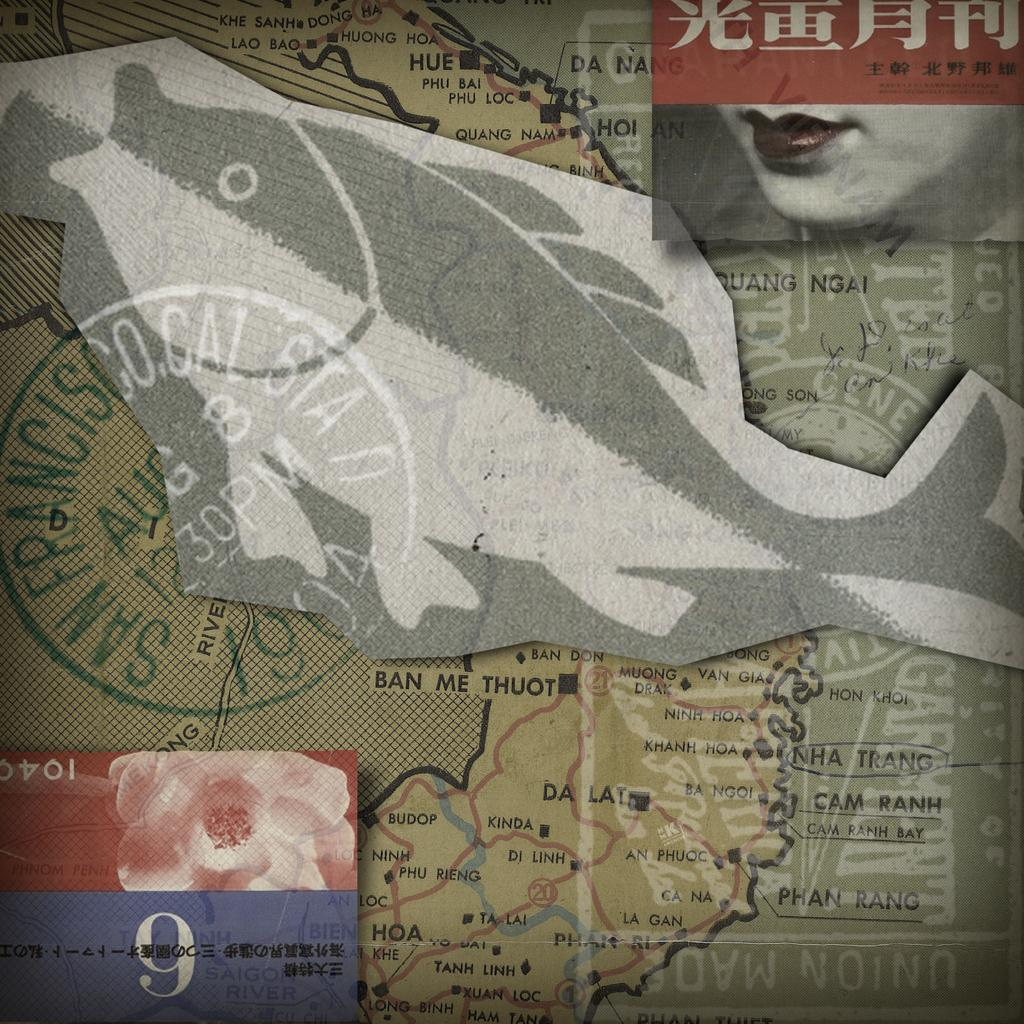What can be observed about the image's appearance? The image appears to be edited. What is the main feature of the image? There is a map in the image. Are there any additional elements on the map? Yes, there are other images on the map. What type of garden can be seen in the image? There is no garden present in the image; it features a map with other images on it. What kind of payment is required to access the apparatus shown in the image? There is no apparatus present in the image, so it is not possible to determine any payment requirements. 